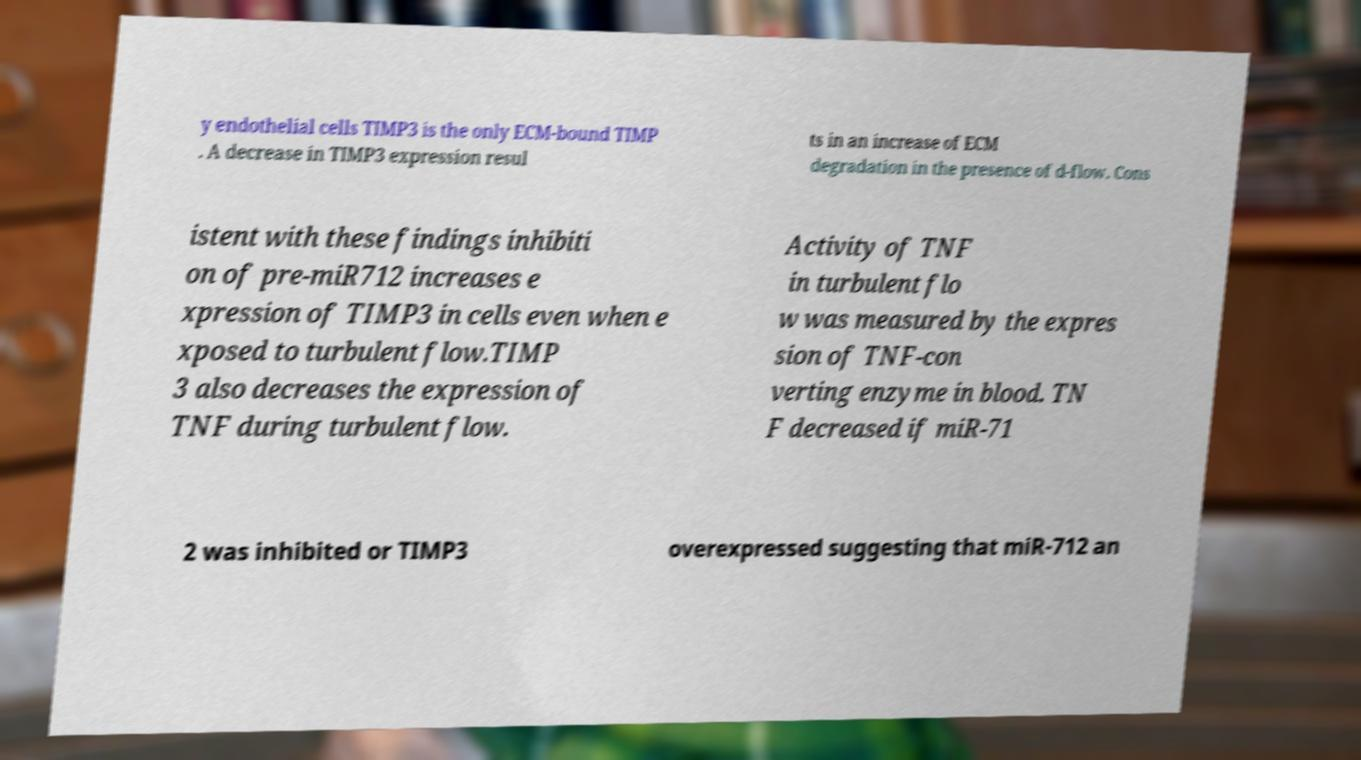There's text embedded in this image that I need extracted. Can you transcribe it verbatim? y endothelial cells TIMP3 is the only ECM-bound TIMP . A decrease in TIMP3 expression resul ts in an increase of ECM degradation in the presence of d-flow. Cons istent with these findings inhibiti on of pre-miR712 increases e xpression of TIMP3 in cells even when e xposed to turbulent flow.TIMP 3 also decreases the expression of TNF during turbulent flow. Activity of TNF in turbulent flo w was measured by the expres sion of TNF-con verting enzyme in blood. TN F decreased if miR-71 2 was inhibited or TIMP3 overexpressed suggesting that miR-712 an 